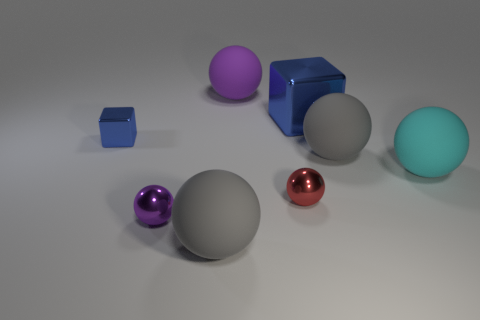What is the mood or atmosphere in this image and what contributes to it? The mood of the image can be described as calm and orderly, due to the neutral background and the evenly spaced arrangement of the objects. The soft lighting and subtle shadows contribute further to the serene atmosphere by creating a harmonious blend of colors and forms. There is no overt activity or chaos, which supports the overall sense of tranquility. 